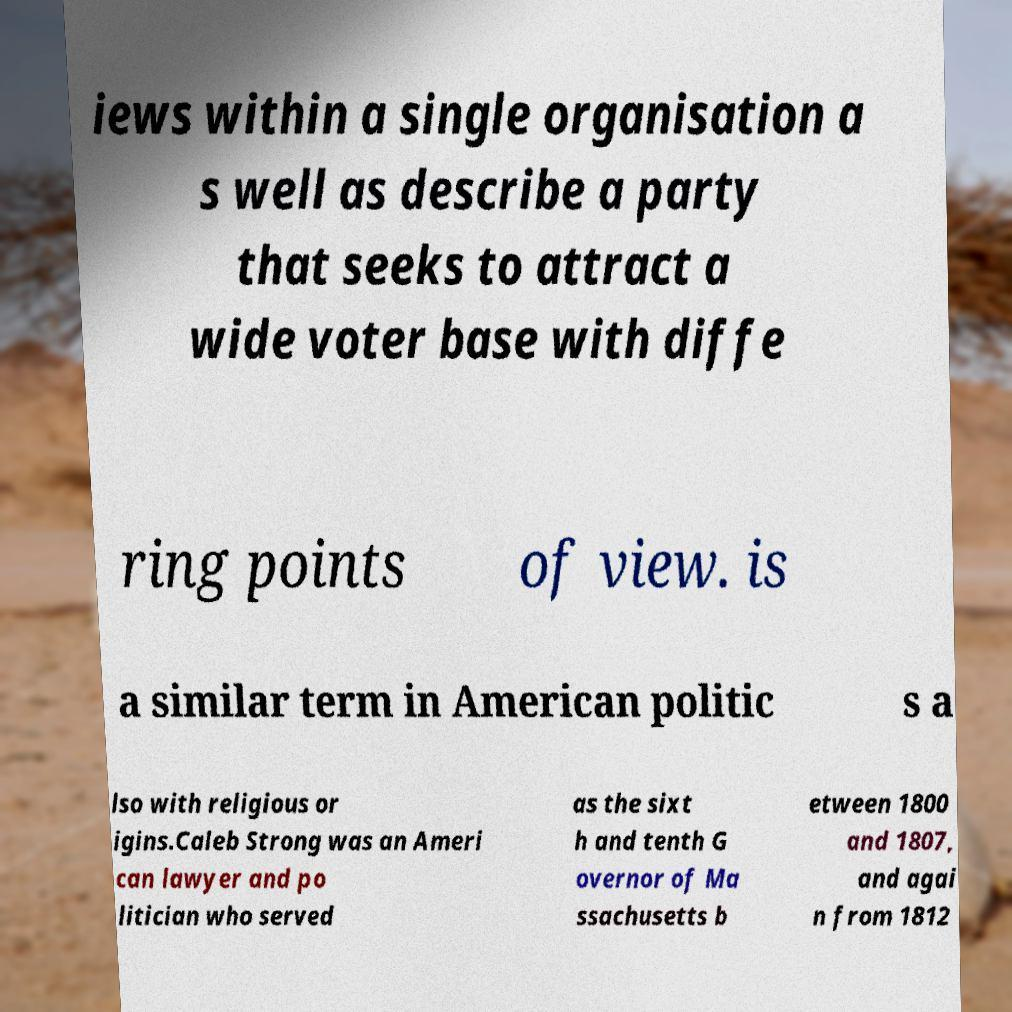I need the written content from this picture converted into text. Can you do that? iews within a single organisation a s well as describe a party that seeks to attract a wide voter base with diffe ring points of view. is a similar term in American politic s a lso with religious or igins.Caleb Strong was an Ameri can lawyer and po litician who served as the sixt h and tenth G overnor of Ma ssachusetts b etween 1800 and 1807, and agai n from 1812 